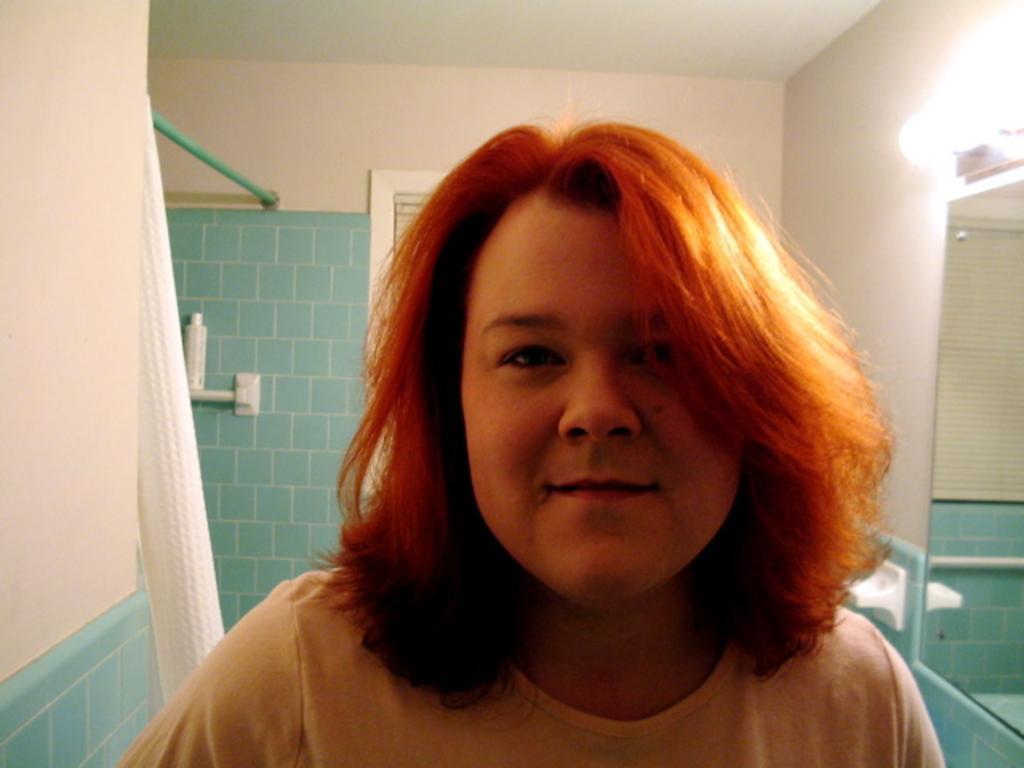Can you describe this image briefly? In this image I can see the person wearing the dress. To the right I can see the mirror and the light to the wall. To the left I can see the bottle and the curtain. 